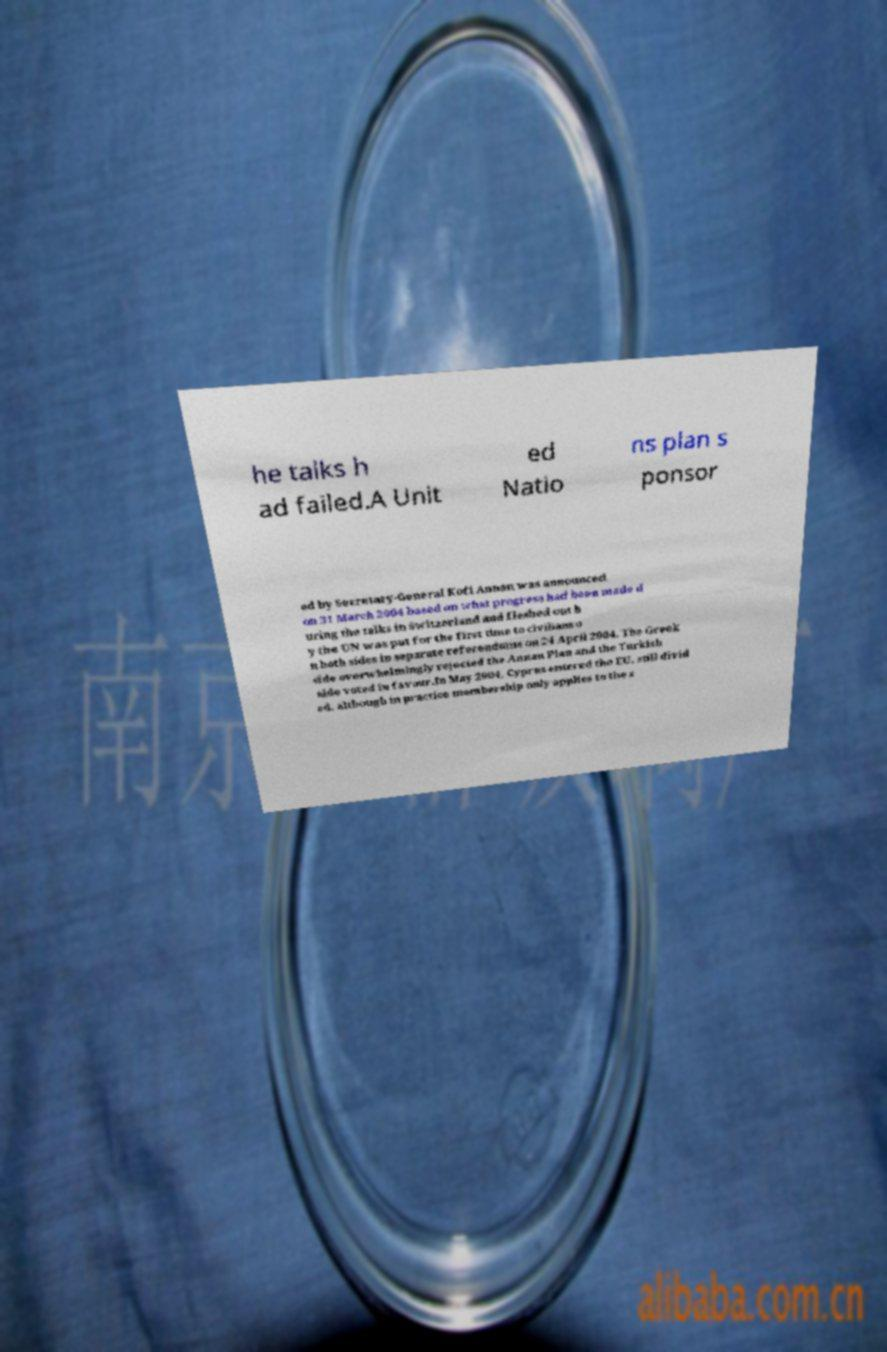I need the written content from this picture converted into text. Can you do that? he talks h ad failed.A Unit ed Natio ns plan s ponsor ed by Secretary-General Kofi Annan was announced on 31 March 2004 based on what progress had been made d uring the talks in Switzerland and fleshed out b y the UN was put for the first time to civilians o n both sides in separate referendums on 24 April 2004. The Greek side overwhelmingly rejected the Annan Plan and the Turkish side voted in favour.In May 2004, Cyprus entered the EU, still divid ed, although in practice membership only applies to the s 